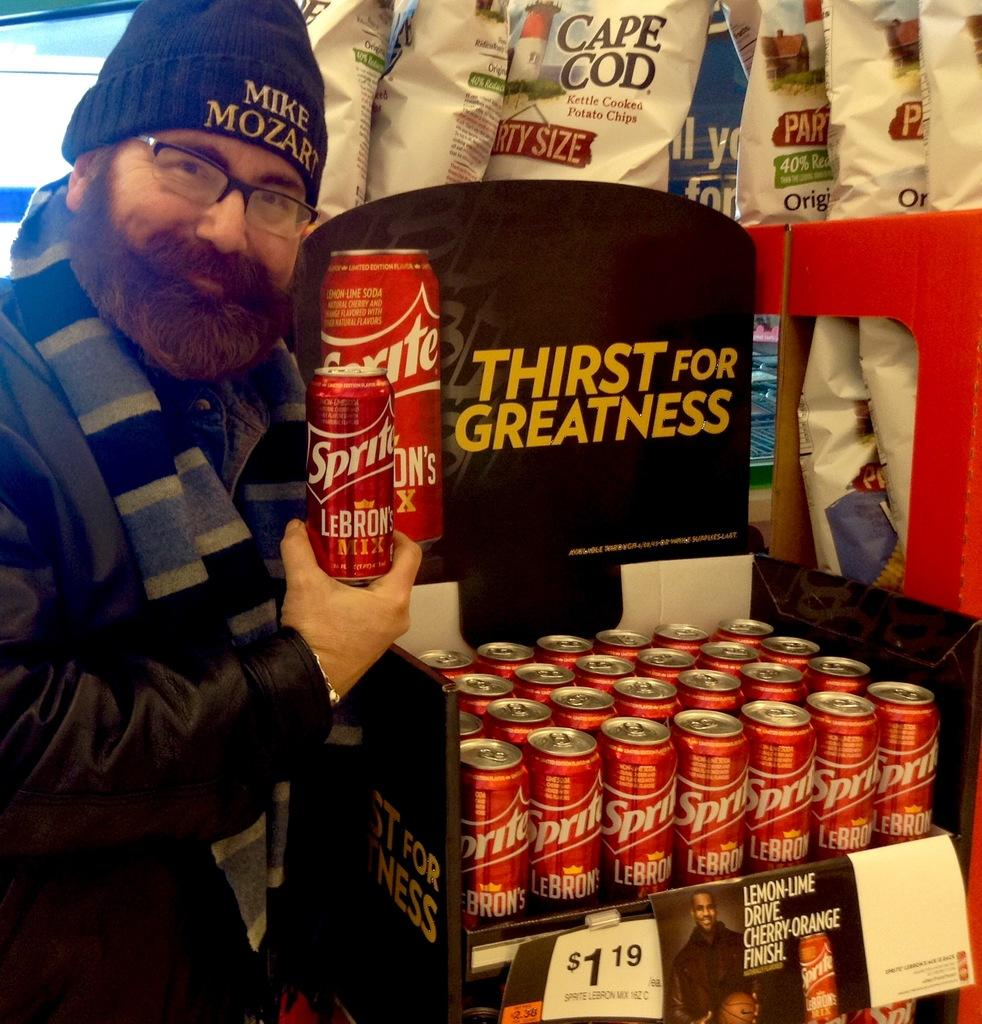<image>
Share a concise interpretation of the image provided. a man with a Sprite can in his hand 